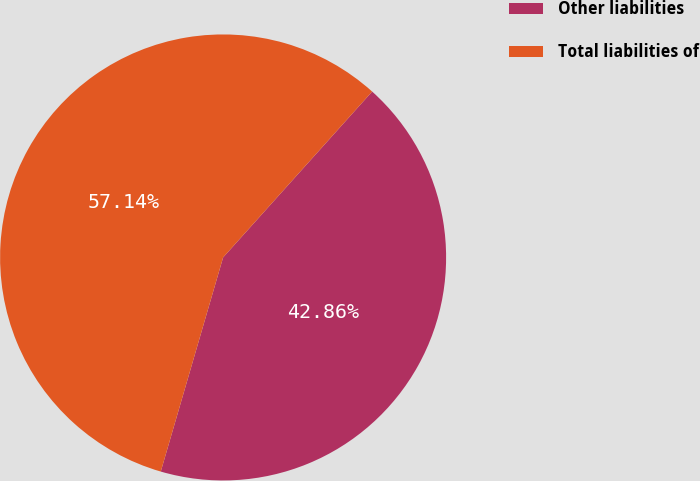Convert chart to OTSL. <chart><loc_0><loc_0><loc_500><loc_500><pie_chart><fcel>Other liabilities<fcel>Total liabilities of<nl><fcel>42.86%<fcel>57.14%<nl></chart> 